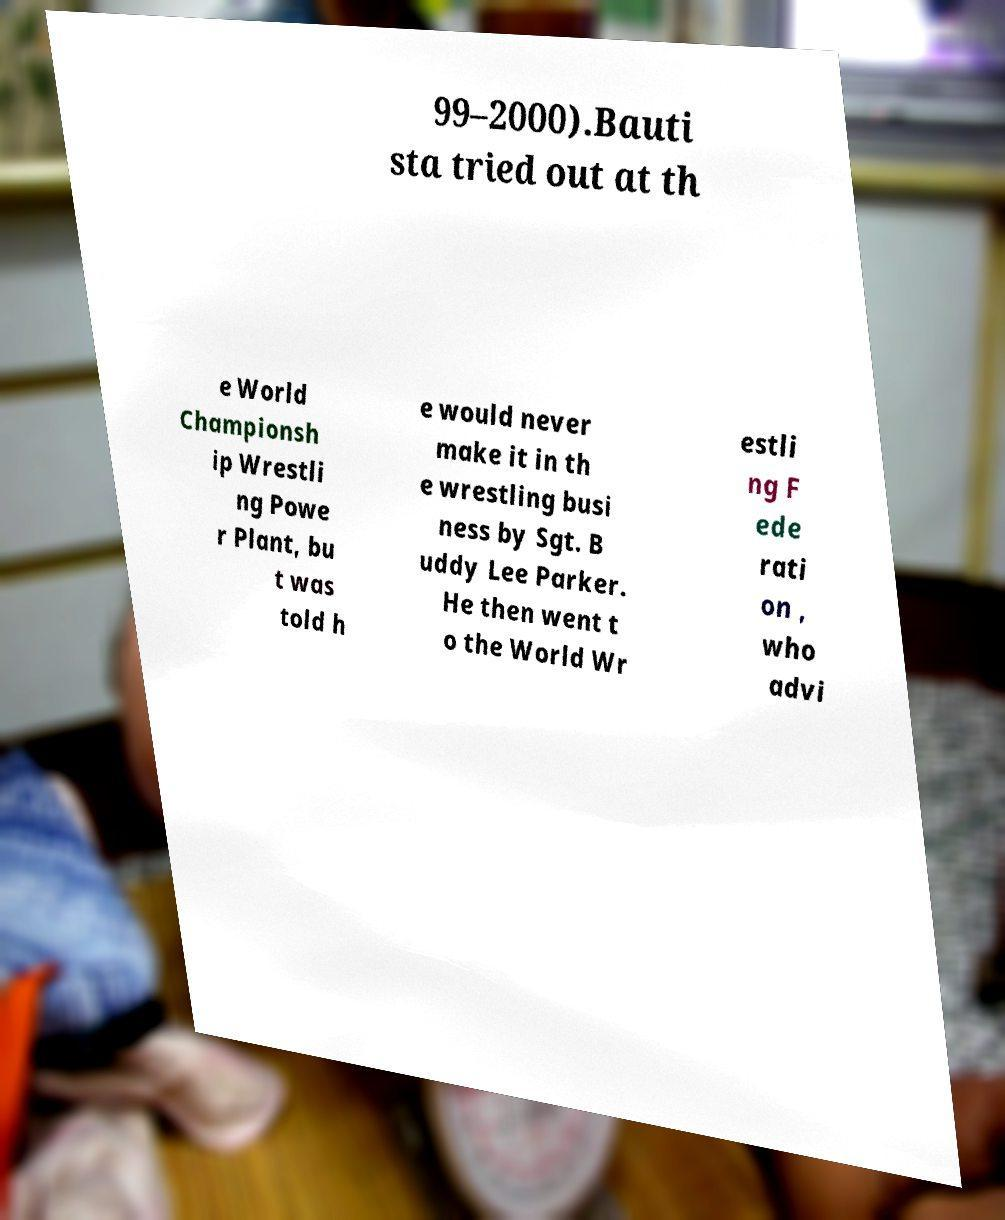Could you assist in decoding the text presented in this image and type it out clearly? 99–2000).Bauti sta tried out at th e World Championsh ip Wrestli ng Powe r Plant, bu t was told h e would never make it in th e wrestling busi ness by Sgt. B uddy Lee Parker. He then went t o the World Wr estli ng F ede rati on , who advi 